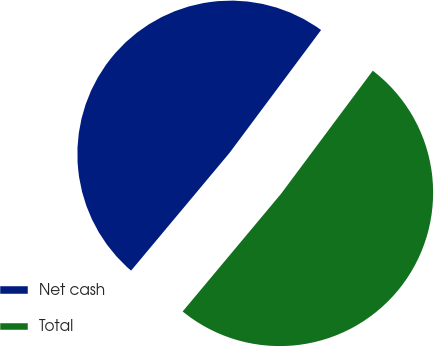Convert chart. <chart><loc_0><loc_0><loc_500><loc_500><pie_chart><fcel>Net cash<fcel>Total<nl><fcel>49.11%<fcel>50.89%<nl></chart> 